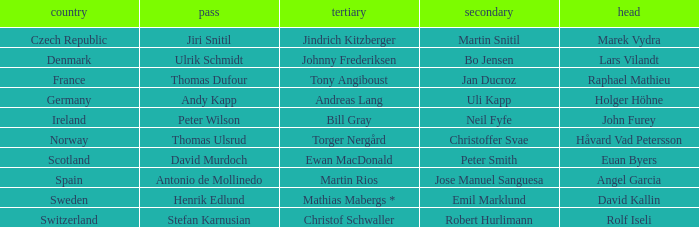Which Skip has a Third of tony angiboust? Thomas Dufour. 